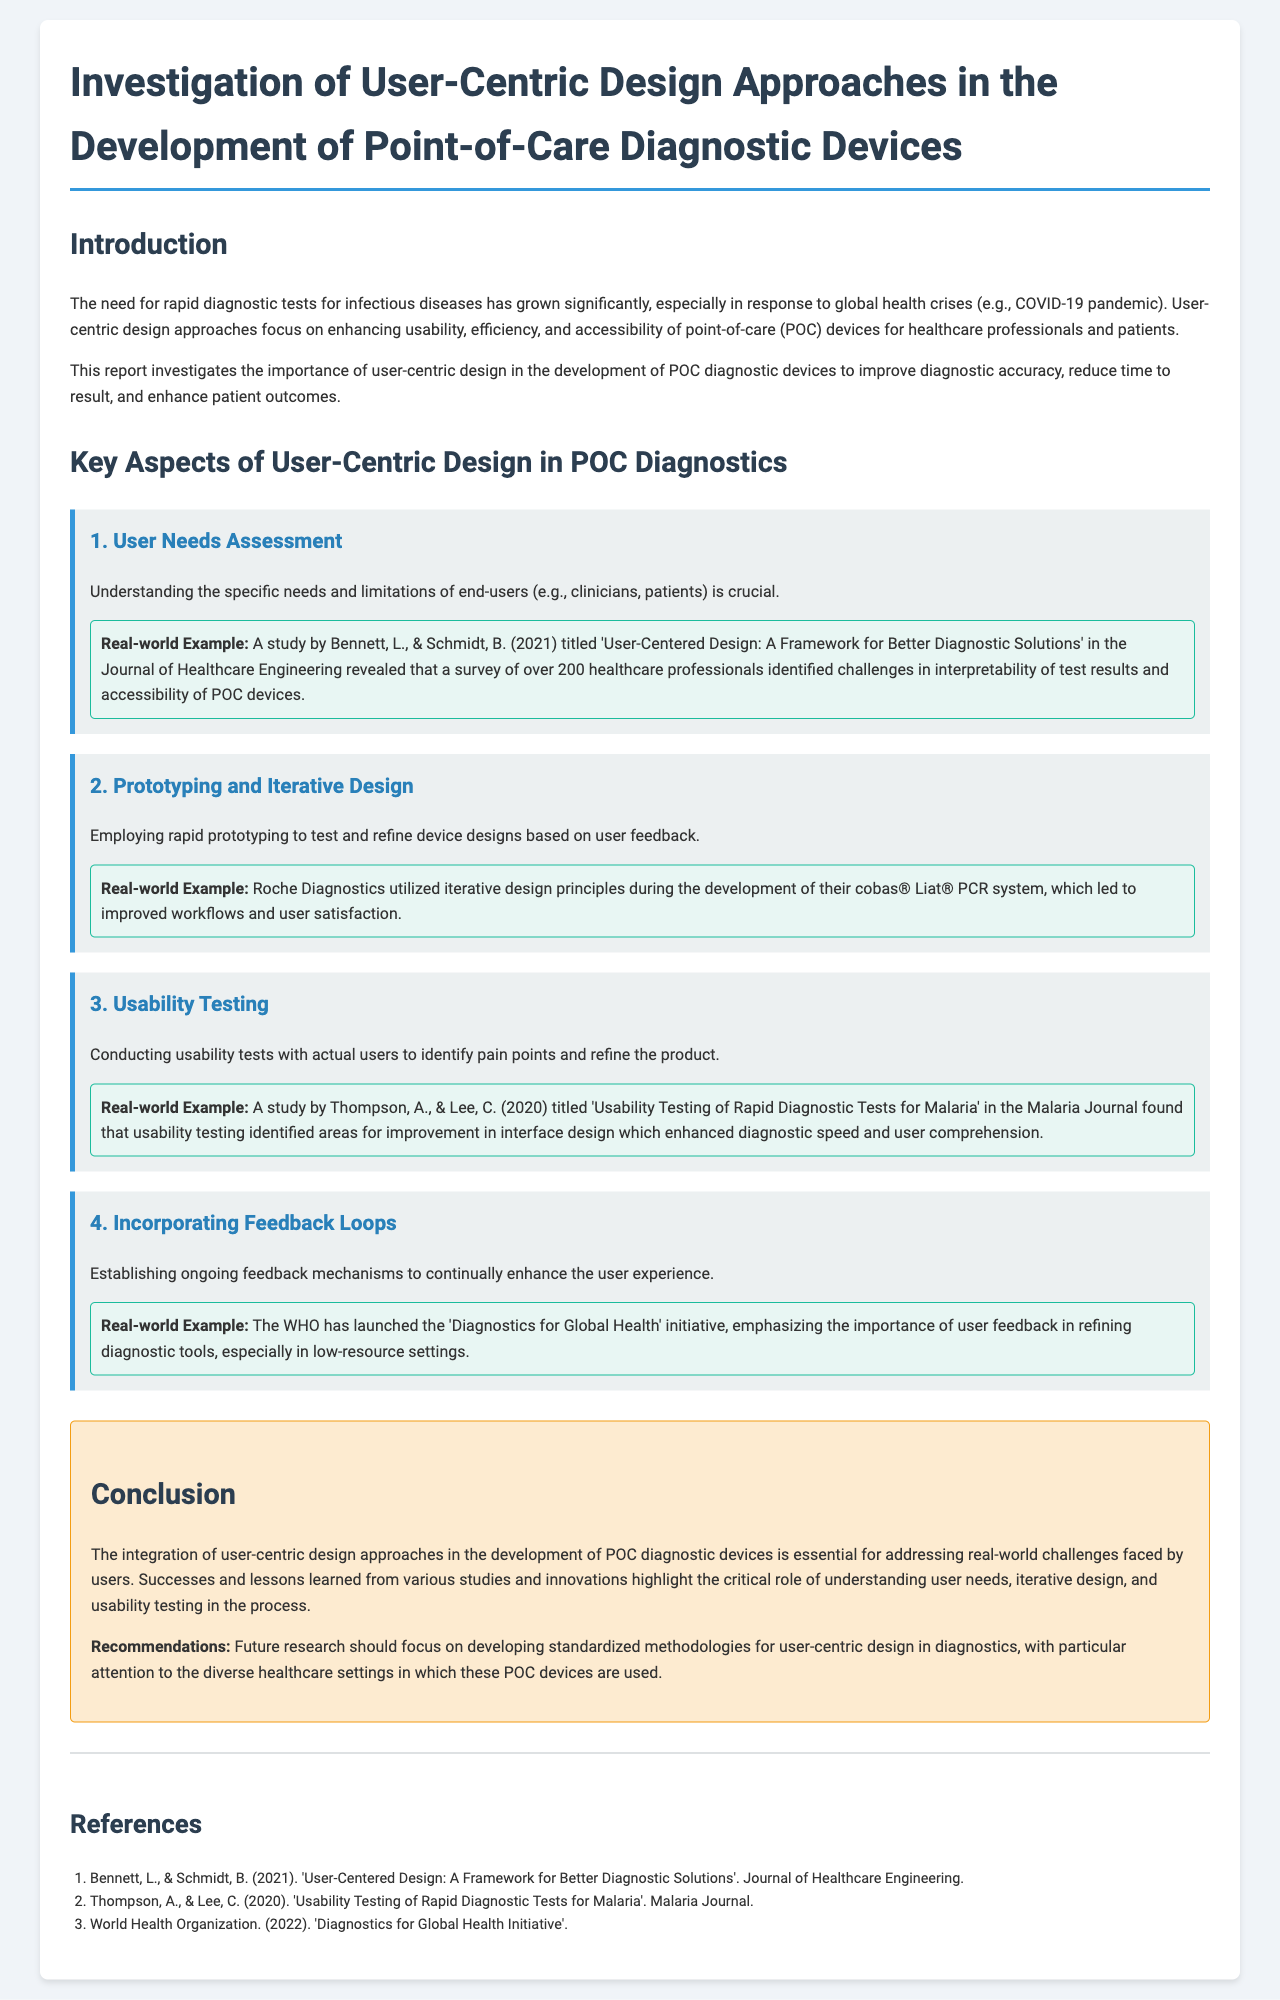What is the main focus of the report? The report focuses on enhancing usability, efficiency, and accessibility of point-of-care devices for healthcare professionals and patients.
Answer: Usability, efficiency, and accessibility What is a key aspect of user-centric design? User needs assessment is identified as a key aspect, emphasizing the importance of understanding end-user needs and limitations.
Answer: User needs assessment What real-world example is provided for usability testing? The study by Thompson, A., & Lee, C. focuses on usability testing of rapid diagnostic tests for malaria, identifying areas for improvement.
Answer: Thompson, A., & Lee, C. (2020) How many healthcare professionals were surveyed in Bennett and Schmidt's study? The study involved a survey of over 200 healthcare professionals regarding the interpretability of test results and device accessibility.
Answer: Over 200 What does the WHO initiative emphasize? The 'Diagnostics for Global Health' initiative emphasizes the importance of user feedback in refining diagnostic tools.
Answer: User feedback What should future research focus on according to the conclusion? The report recommends focusing on developing standardized methodologies for user-centric design in diagnostics.
Answer: Standardized methodologies What is the publication year of the referenced study by Bennett and Schmidt? The study was published in 2021, detailing a framework for better diagnostic solutions.
Answer: 2021 What is one recommendation made in the report? One recommendation is to develop standardized methodologies for user-centric design in diagnostics.
Answer: Standardized methodologies 